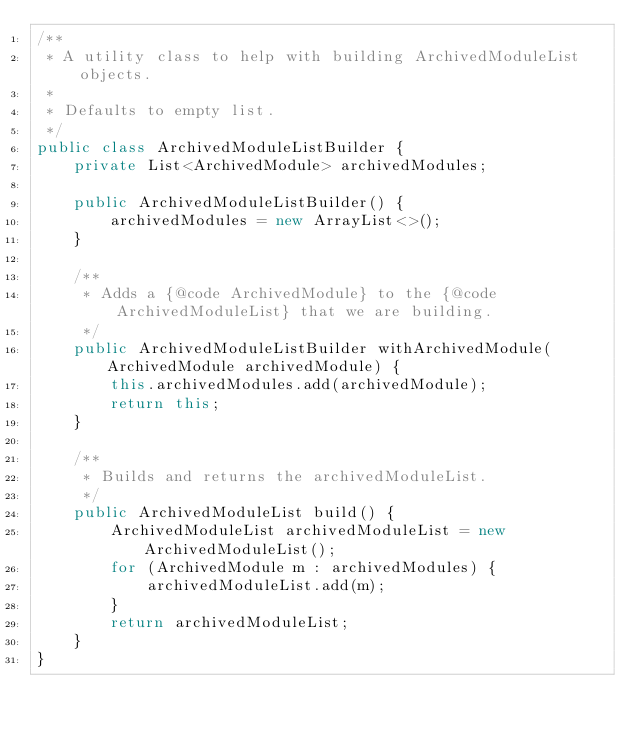Convert code to text. <code><loc_0><loc_0><loc_500><loc_500><_Java_>/**
 * A utility class to help with building ArchivedModuleList objects.
 *
 * Defaults to empty list.
 */
public class ArchivedModuleListBuilder {
    private List<ArchivedModule> archivedModules;

    public ArchivedModuleListBuilder() {
        archivedModules = new ArrayList<>();
    }

    /**
     * Adds a {@code ArchivedModule} to the {@code ArchivedModuleList} that we are building.
     */
    public ArchivedModuleListBuilder withArchivedModule(ArchivedModule archivedModule) {
        this.archivedModules.add(archivedModule);
        return this;
    }

    /**
     * Builds and returns the archivedModuleList.
     */
    public ArchivedModuleList build() {
        ArchivedModuleList archivedModuleList = new ArchivedModuleList();
        for (ArchivedModule m : archivedModules) {
            archivedModuleList.add(m);
        }
        return archivedModuleList;
    }
}
</code> 